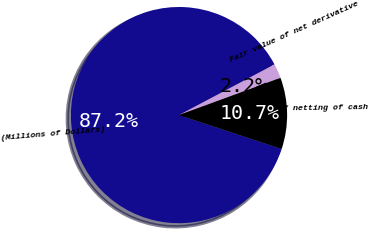Convert chart. <chart><loc_0><loc_0><loc_500><loc_500><pie_chart><fcel>(Millions of Dollars)<fcel>Fair value of net derivative<fcel>Impact of netting of cash<nl><fcel>87.16%<fcel>2.17%<fcel>10.67%<nl></chart> 